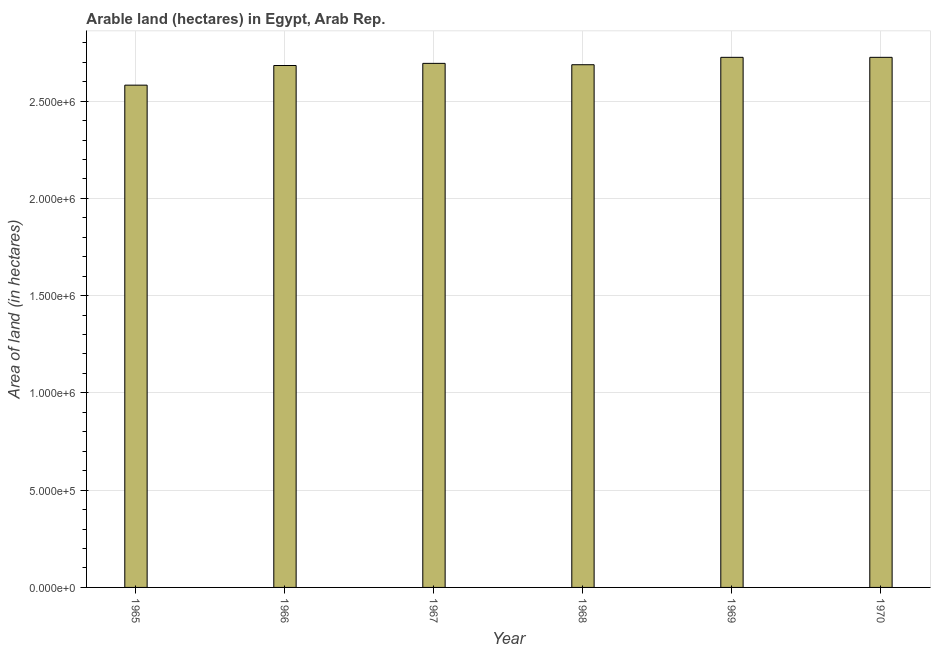What is the title of the graph?
Your answer should be compact. Arable land (hectares) in Egypt, Arab Rep. What is the label or title of the Y-axis?
Provide a succinct answer. Area of land (in hectares). What is the area of land in 1965?
Your response must be concise. 2.58e+06. Across all years, what is the maximum area of land?
Make the answer very short. 2.72e+06. Across all years, what is the minimum area of land?
Provide a succinct answer. 2.58e+06. In which year was the area of land maximum?
Ensure brevity in your answer.  1969. In which year was the area of land minimum?
Ensure brevity in your answer.  1965. What is the sum of the area of land?
Provide a succinct answer. 1.61e+07. What is the difference between the area of land in 1967 and 1970?
Provide a succinct answer. -3.10e+04. What is the average area of land per year?
Offer a terse response. 2.68e+06. What is the median area of land?
Offer a very short reply. 2.69e+06. Do a majority of the years between 1967 and 1968 (inclusive) have area of land greater than 300000 hectares?
Keep it short and to the point. Yes. What is the ratio of the area of land in 1968 to that in 1969?
Give a very brief answer. 0.99. Is the area of land in 1968 less than that in 1970?
Offer a terse response. Yes. What is the difference between the highest and the second highest area of land?
Keep it short and to the point. 0. Is the sum of the area of land in 1968 and 1969 greater than the maximum area of land across all years?
Offer a very short reply. Yes. What is the difference between the highest and the lowest area of land?
Ensure brevity in your answer.  1.43e+05. In how many years, is the area of land greater than the average area of land taken over all years?
Your answer should be compact. 5. Are all the bars in the graph horizontal?
Provide a succinct answer. No. How many years are there in the graph?
Your answer should be compact. 6. What is the difference between two consecutive major ticks on the Y-axis?
Ensure brevity in your answer.  5.00e+05. What is the Area of land (in hectares) of 1965?
Your answer should be compact. 2.58e+06. What is the Area of land (in hectares) in 1966?
Offer a very short reply. 2.68e+06. What is the Area of land (in hectares) in 1967?
Your response must be concise. 2.69e+06. What is the Area of land (in hectares) of 1968?
Provide a succinct answer. 2.69e+06. What is the Area of land (in hectares) of 1969?
Your answer should be very brief. 2.72e+06. What is the Area of land (in hectares) of 1970?
Offer a very short reply. 2.72e+06. What is the difference between the Area of land (in hectares) in 1965 and 1966?
Offer a terse response. -1.01e+05. What is the difference between the Area of land (in hectares) in 1965 and 1967?
Offer a very short reply. -1.12e+05. What is the difference between the Area of land (in hectares) in 1965 and 1968?
Your response must be concise. -1.05e+05. What is the difference between the Area of land (in hectares) in 1965 and 1969?
Keep it short and to the point. -1.43e+05. What is the difference between the Area of land (in hectares) in 1965 and 1970?
Make the answer very short. -1.43e+05. What is the difference between the Area of land (in hectares) in 1966 and 1967?
Keep it short and to the point. -1.10e+04. What is the difference between the Area of land (in hectares) in 1966 and 1968?
Keep it short and to the point. -4000. What is the difference between the Area of land (in hectares) in 1966 and 1969?
Provide a succinct answer. -4.20e+04. What is the difference between the Area of land (in hectares) in 1966 and 1970?
Keep it short and to the point. -4.20e+04. What is the difference between the Area of land (in hectares) in 1967 and 1968?
Provide a succinct answer. 7000. What is the difference between the Area of land (in hectares) in 1967 and 1969?
Your answer should be very brief. -3.10e+04. What is the difference between the Area of land (in hectares) in 1967 and 1970?
Give a very brief answer. -3.10e+04. What is the difference between the Area of land (in hectares) in 1968 and 1969?
Your answer should be compact. -3.80e+04. What is the difference between the Area of land (in hectares) in 1968 and 1970?
Give a very brief answer. -3.80e+04. What is the difference between the Area of land (in hectares) in 1969 and 1970?
Offer a very short reply. 0. What is the ratio of the Area of land (in hectares) in 1965 to that in 1967?
Ensure brevity in your answer.  0.96. What is the ratio of the Area of land (in hectares) in 1965 to that in 1968?
Your answer should be compact. 0.96. What is the ratio of the Area of land (in hectares) in 1965 to that in 1969?
Keep it short and to the point. 0.95. What is the ratio of the Area of land (in hectares) in 1965 to that in 1970?
Your response must be concise. 0.95. What is the ratio of the Area of land (in hectares) in 1966 to that in 1968?
Offer a terse response. 1. What is the ratio of the Area of land (in hectares) in 1966 to that in 1969?
Offer a terse response. 0.98. What is the ratio of the Area of land (in hectares) in 1966 to that in 1970?
Offer a very short reply. 0.98. What is the ratio of the Area of land (in hectares) in 1967 to that in 1969?
Provide a succinct answer. 0.99. What is the ratio of the Area of land (in hectares) in 1967 to that in 1970?
Offer a very short reply. 0.99. What is the ratio of the Area of land (in hectares) in 1968 to that in 1969?
Your response must be concise. 0.99. What is the ratio of the Area of land (in hectares) in 1968 to that in 1970?
Make the answer very short. 0.99. 